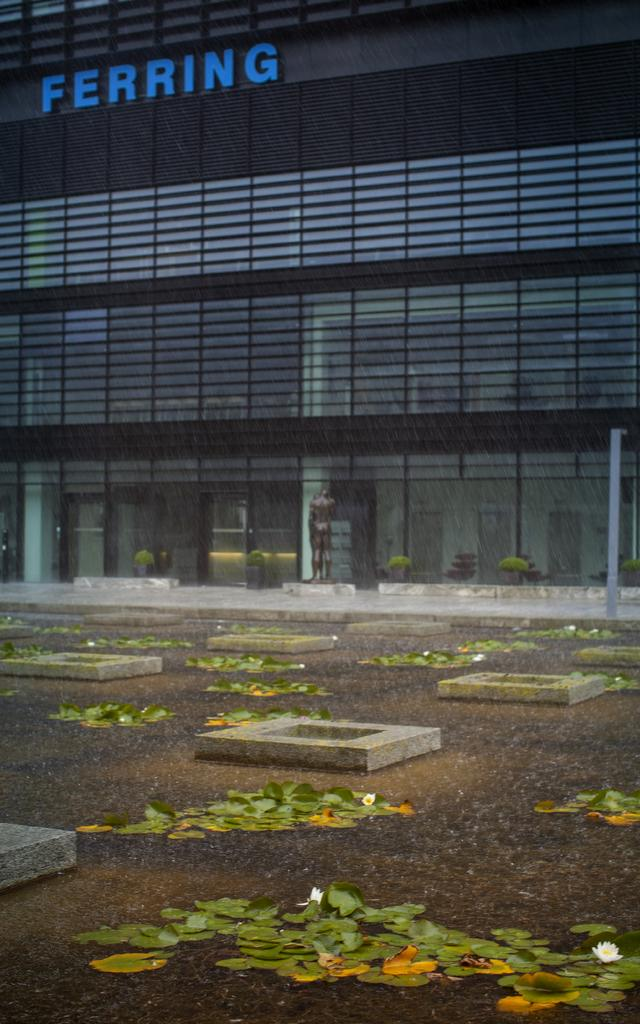What is the main structure visible in the image? There is a building in the image. Can you describe any specific features of the building? The building has a name written in blue color. What else can be seen in the image besides the building? There are leaves on the water in the image. How many trains can be seen passing by the building in the image? There are no trains visible in the image; it only features a building and leaves on the water. 